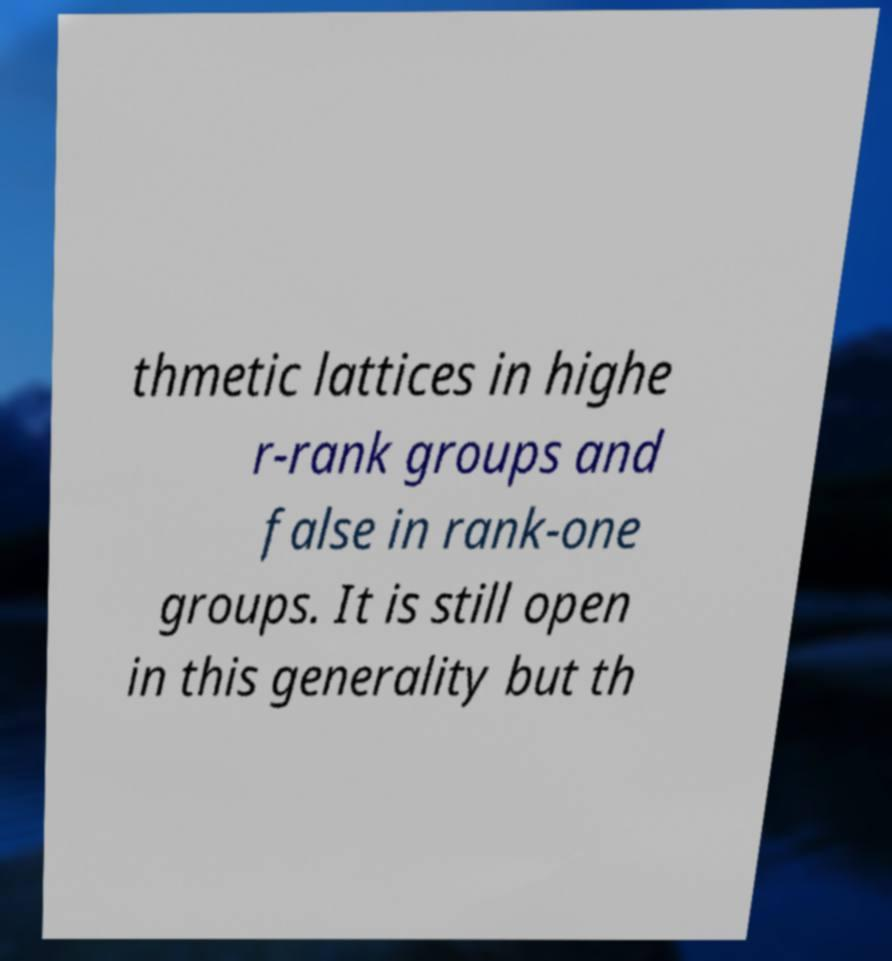Could you assist in decoding the text presented in this image and type it out clearly? thmetic lattices in highe r-rank groups and false in rank-one groups. It is still open in this generality but th 